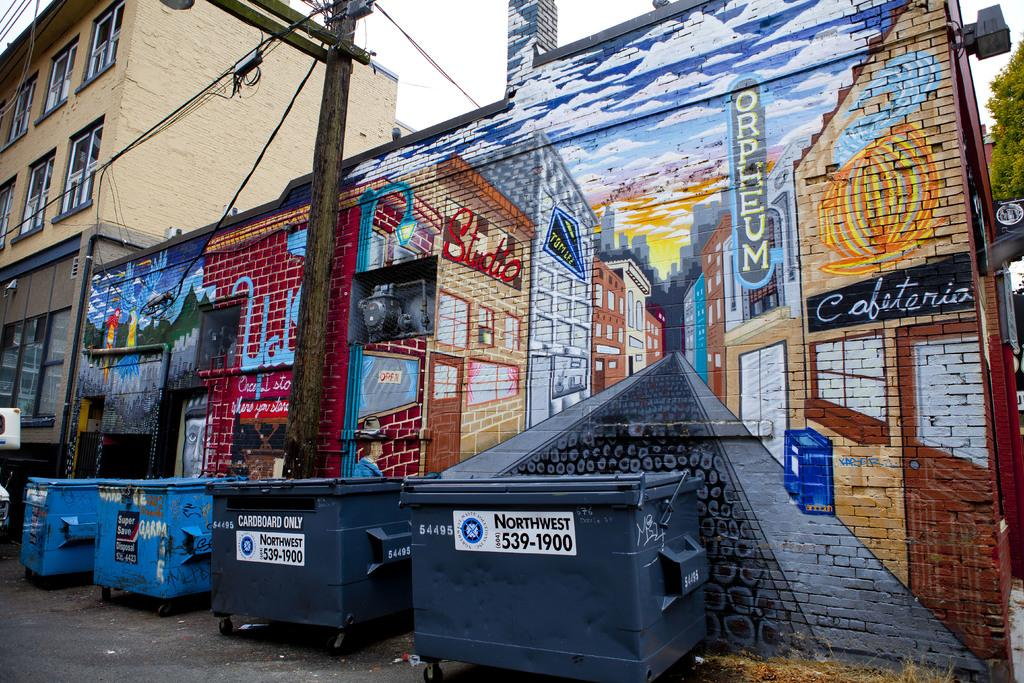<image>
Describe the image concisely. A painted wall outdoors with several dumpsters lined up against it, including one that is for cardboard only. 